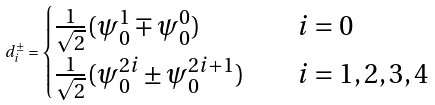Convert formula to latex. <formula><loc_0><loc_0><loc_500><loc_500>d _ { i } ^ { \pm } = \begin{cases} \frac { 1 } { \sqrt { 2 } } ( \psi _ { 0 } ^ { 1 } \mp \psi _ { 0 } ^ { 0 } ) \quad & i = 0 \\ \frac { 1 } { \sqrt { 2 } } ( \psi _ { 0 } ^ { 2 i } \pm \psi _ { 0 } ^ { 2 i + 1 } ) \quad & i = 1 , 2 , 3 , 4 \end{cases}</formula> 